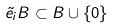Convert formula to latex. <formula><loc_0><loc_0><loc_500><loc_500>\tilde { e } _ { i } B \subset B \cup \{ 0 \}</formula> 